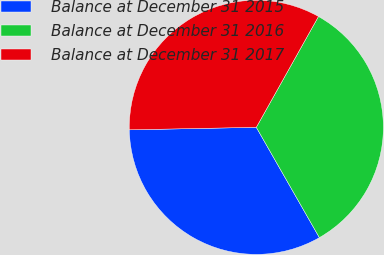<chart> <loc_0><loc_0><loc_500><loc_500><pie_chart><fcel>Balance at December 31 2015<fcel>Balance at December 31 2016<fcel>Balance at December 31 2017<nl><fcel>32.95%<fcel>33.6%<fcel>33.45%<nl></chart> 